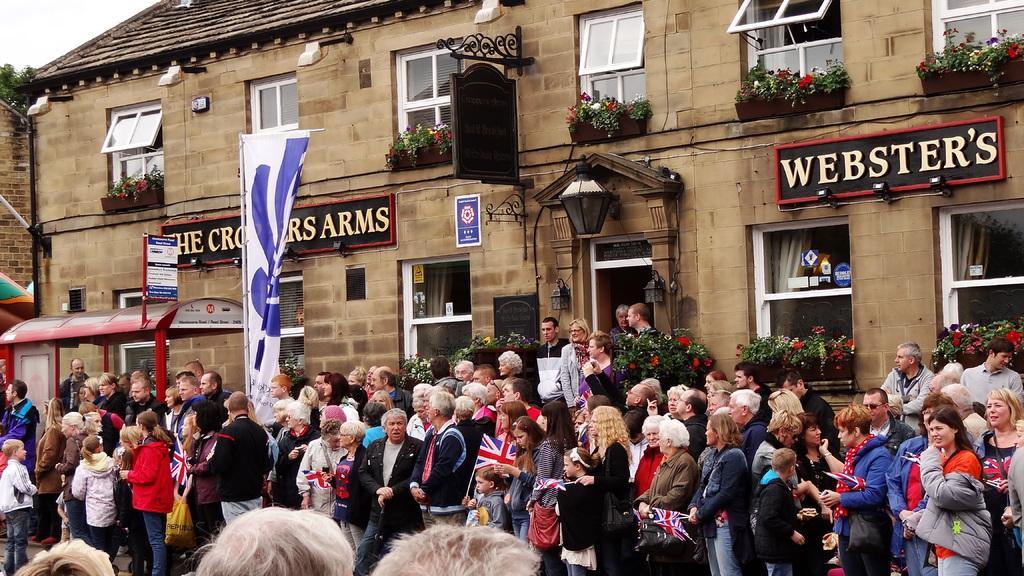Describe this image in one or two sentences. In the image there are many people standing in front of building, there are many windows to the wall and a flag hanging to it and above its sky. 